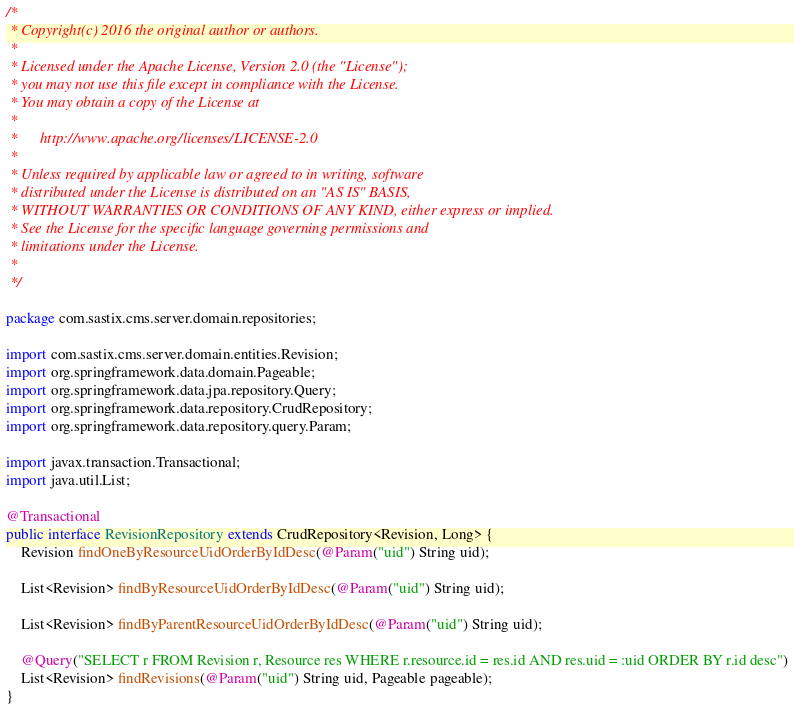<code> <loc_0><loc_0><loc_500><loc_500><_Java_>/*
 * Copyright(c) 2016 the original author or authors.
 *
 * Licensed under the Apache License, Version 2.0 (the "License");
 * you may not use this file except in compliance with the License.
 * You may obtain a copy of the License at
 *
 *      http://www.apache.org/licenses/LICENSE-2.0
 *
 * Unless required by applicable law or agreed to in writing, software
 * distributed under the License is distributed on an "AS IS" BASIS,
 * WITHOUT WARRANTIES OR CONDITIONS OF ANY KIND, either express or implied.
 * See the License for the specific language governing permissions and
 * limitations under the License.
 *
 */

package com.sastix.cms.server.domain.repositories;

import com.sastix.cms.server.domain.entities.Revision;
import org.springframework.data.domain.Pageable;
import org.springframework.data.jpa.repository.Query;
import org.springframework.data.repository.CrudRepository;
import org.springframework.data.repository.query.Param;

import javax.transaction.Transactional;
import java.util.List;

@Transactional
public interface RevisionRepository extends CrudRepository<Revision, Long> {
    Revision findOneByResourceUidOrderByIdDesc(@Param("uid") String uid);

    List<Revision> findByResourceUidOrderByIdDesc(@Param("uid") String uid);

    List<Revision> findByParentResourceUidOrderByIdDesc(@Param("uid") String uid);

    @Query("SELECT r FROM Revision r, Resource res WHERE r.resource.id = res.id AND res.uid = :uid ORDER BY r.id desc")
    List<Revision> findRevisions(@Param("uid") String uid, Pageable pageable);
}
</code> 